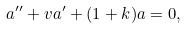<formula> <loc_0><loc_0><loc_500><loc_500>a ^ { \prime \prime } + v a ^ { \prime } + ( 1 + k ) a = 0 ,</formula> 